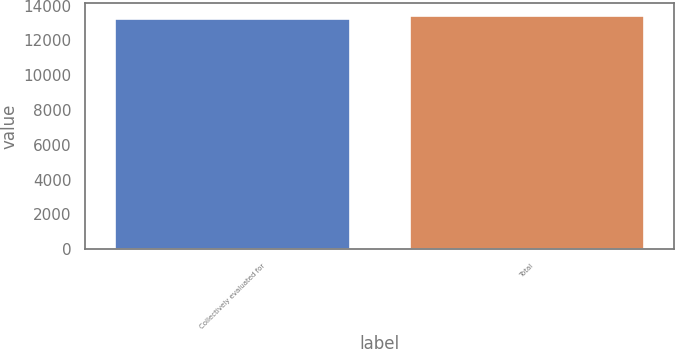<chart> <loc_0><loc_0><loc_500><loc_500><bar_chart><fcel>Collectively evaluated for<fcel>Total<nl><fcel>13280<fcel>13486<nl></chart> 